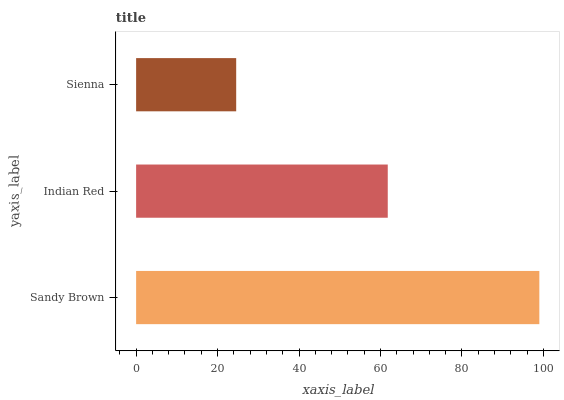Is Sienna the minimum?
Answer yes or no. Yes. Is Sandy Brown the maximum?
Answer yes or no. Yes. Is Indian Red the minimum?
Answer yes or no. No. Is Indian Red the maximum?
Answer yes or no. No. Is Sandy Brown greater than Indian Red?
Answer yes or no. Yes. Is Indian Red less than Sandy Brown?
Answer yes or no. Yes. Is Indian Red greater than Sandy Brown?
Answer yes or no. No. Is Sandy Brown less than Indian Red?
Answer yes or no. No. Is Indian Red the high median?
Answer yes or no. Yes. Is Indian Red the low median?
Answer yes or no. Yes. Is Sandy Brown the high median?
Answer yes or no. No. Is Sienna the low median?
Answer yes or no. No. 